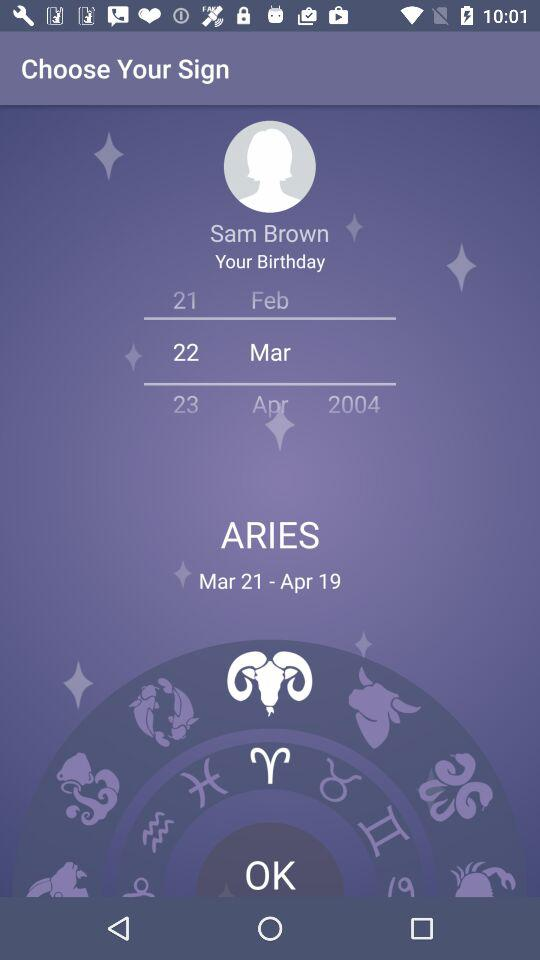Which sign is selected? The selected sign is "ARIES". 